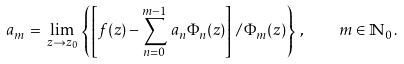Convert formula to latex. <formula><loc_0><loc_0><loc_500><loc_500>a _ { m } \, = \, \lim _ { z \to z _ { 0 } } \, \left \{ \left [ f ( z ) - \sum _ { n = 0 } ^ { m - 1 } \, a _ { n } \Phi _ { n } ( z ) \right ] \, / \, \Phi _ { m } ( z ) \right \} \, , \quad m \in \mathbb { N } _ { 0 } \, .</formula> 